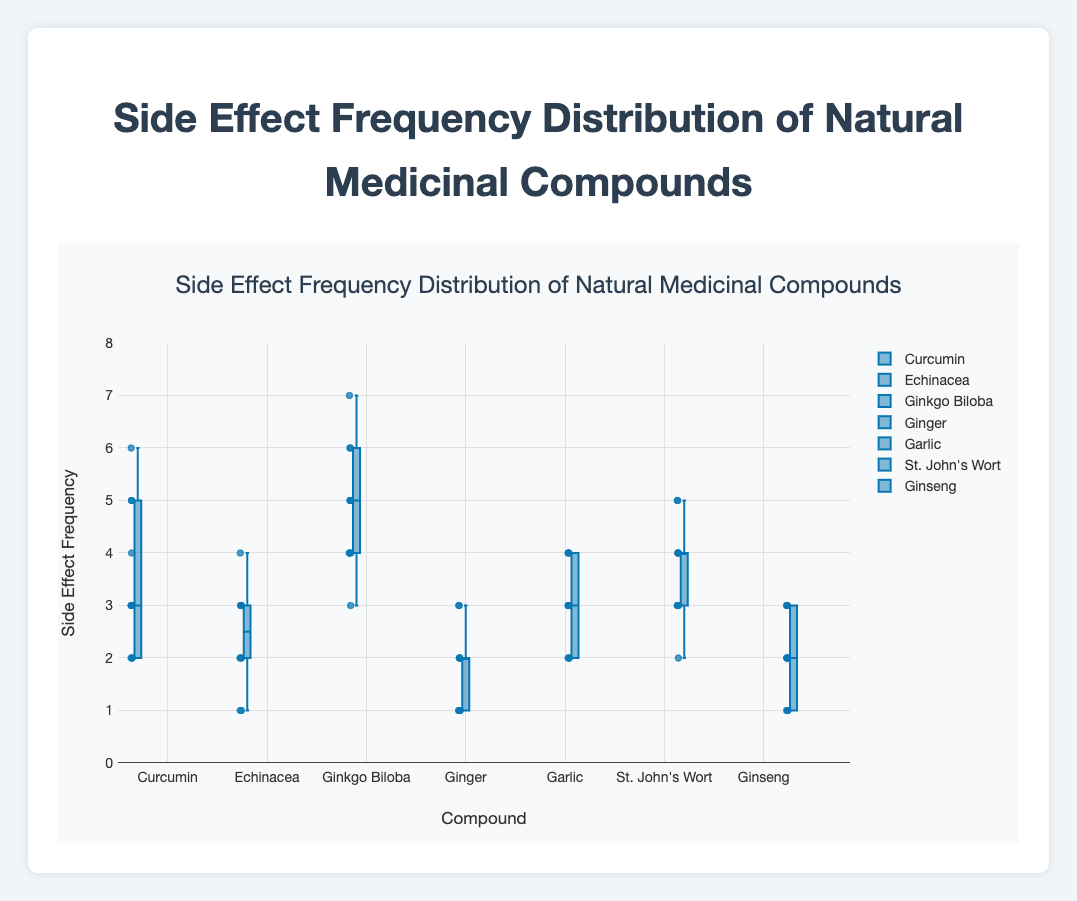What's the title of the figure? The title is the text at the top of the figure. In this case, it reads "Side Effect Frequency Distribution of Natural Medicinal Compounds".
Answer: Side Effect Frequency Distribution of Natural Medicinal Compounds What's the y-axis labeled as? The label of the y-axis is provided in the figure and reads "Side Effect Frequency".
Answer: Side Effect Frequency Which compound has the highest median side effect frequency? By observing the median lines inside the boxes, Ginkgo Biloba has the highest median side effect frequency.
Answer: Ginkgo Biloba How many compounds have a lower quartile value of 2? By looking at the lower quartile (bottom of the boxes), Curcumin, Garlic, and St. John's Wort have a lower quartile value of 2.
Answer: 3 Which compound has the smallest range of side effect frequency values? The range can be determined by subtracting the minimum from the maximum values (whiskers). Ginger has the smallest range (1 to 3).
Answer: Ginger What is the interquartile range (IQR) of side effect frequency for Echinacea? The IQR is the difference between the upper and lower quartiles. For Echinacea, it's 3 (upper) - 2 (lower) = 1.
Answer: 1 How do the side effect frequencies of Ginseng and Ginger compare? Both Ginseng and Ginger show a similar spread in side effect frequencies, with many data points overlapping. Both have median values close to the lower end (approximately 2 or less).
Answer: Similar What is the maximum side effect frequency observed in St. John's Wort? The maximum value can be determined from the top whisker of the box. For St. John's Wort, it is 5.
Answer: 5 Which compound appears to have the most outliers? Outliers are represented by individual points outside the whiskers. Curcumin has several outliers, indicating a higher spread.
Answer: Curcumin 